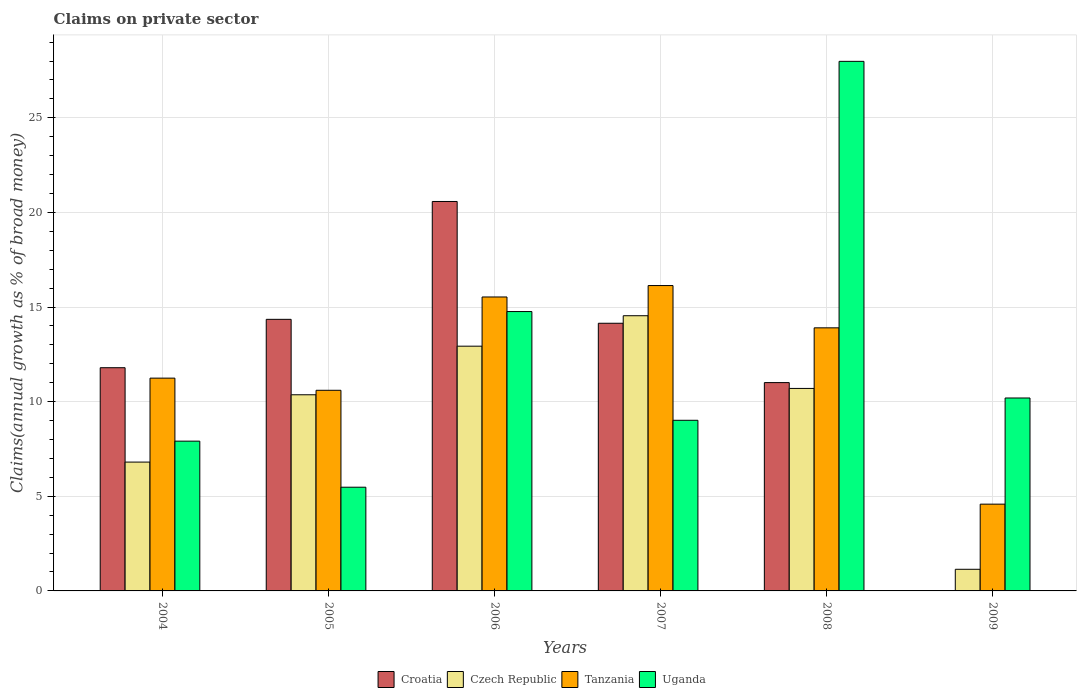How many different coloured bars are there?
Make the answer very short. 4. How many bars are there on the 1st tick from the right?
Your answer should be compact. 3. What is the percentage of broad money claimed on private sector in Czech Republic in 2007?
Provide a succinct answer. 14.54. Across all years, what is the maximum percentage of broad money claimed on private sector in Tanzania?
Offer a terse response. 16.14. In which year was the percentage of broad money claimed on private sector in Uganda maximum?
Provide a succinct answer. 2008. What is the total percentage of broad money claimed on private sector in Czech Republic in the graph?
Give a very brief answer. 56.49. What is the difference between the percentage of broad money claimed on private sector in Croatia in 2004 and that in 2006?
Provide a short and direct response. -8.78. What is the difference between the percentage of broad money claimed on private sector in Tanzania in 2005 and the percentage of broad money claimed on private sector in Croatia in 2004?
Offer a terse response. -1.19. What is the average percentage of broad money claimed on private sector in Croatia per year?
Offer a terse response. 11.98. In the year 2004, what is the difference between the percentage of broad money claimed on private sector in Tanzania and percentage of broad money claimed on private sector in Uganda?
Keep it short and to the point. 3.33. What is the ratio of the percentage of broad money claimed on private sector in Croatia in 2004 to that in 2007?
Make the answer very short. 0.83. What is the difference between the highest and the second highest percentage of broad money claimed on private sector in Croatia?
Your answer should be compact. 6.23. What is the difference between the highest and the lowest percentage of broad money claimed on private sector in Czech Republic?
Keep it short and to the point. 13.4. Is the sum of the percentage of broad money claimed on private sector in Czech Republic in 2004 and 2005 greater than the maximum percentage of broad money claimed on private sector in Croatia across all years?
Keep it short and to the point. No. Is it the case that in every year, the sum of the percentage of broad money claimed on private sector in Croatia and percentage of broad money claimed on private sector in Czech Republic is greater than the sum of percentage of broad money claimed on private sector in Uganda and percentage of broad money claimed on private sector in Tanzania?
Your response must be concise. No. How many years are there in the graph?
Provide a succinct answer. 6. Are the values on the major ticks of Y-axis written in scientific E-notation?
Offer a very short reply. No. Does the graph contain grids?
Your answer should be compact. Yes. How many legend labels are there?
Your answer should be very brief. 4. How are the legend labels stacked?
Keep it short and to the point. Horizontal. What is the title of the graph?
Give a very brief answer. Claims on private sector. Does "New Zealand" appear as one of the legend labels in the graph?
Your answer should be very brief. No. What is the label or title of the Y-axis?
Make the answer very short. Claims(annual growth as % of broad money). What is the Claims(annual growth as % of broad money) of Croatia in 2004?
Ensure brevity in your answer.  11.8. What is the Claims(annual growth as % of broad money) of Czech Republic in 2004?
Keep it short and to the point. 6.81. What is the Claims(annual growth as % of broad money) in Tanzania in 2004?
Provide a succinct answer. 11.24. What is the Claims(annual growth as % of broad money) in Uganda in 2004?
Provide a succinct answer. 7.91. What is the Claims(annual growth as % of broad money) in Croatia in 2005?
Make the answer very short. 14.35. What is the Claims(annual growth as % of broad money) in Czech Republic in 2005?
Keep it short and to the point. 10.37. What is the Claims(annual growth as % of broad money) in Tanzania in 2005?
Provide a short and direct response. 10.6. What is the Claims(annual growth as % of broad money) in Uganda in 2005?
Give a very brief answer. 5.48. What is the Claims(annual growth as % of broad money) in Croatia in 2006?
Ensure brevity in your answer.  20.58. What is the Claims(annual growth as % of broad money) in Czech Republic in 2006?
Offer a very short reply. 12.93. What is the Claims(annual growth as % of broad money) of Tanzania in 2006?
Offer a terse response. 15.53. What is the Claims(annual growth as % of broad money) in Uganda in 2006?
Make the answer very short. 14.76. What is the Claims(annual growth as % of broad money) in Croatia in 2007?
Give a very brief answer. 14.14. What is the Claims(annual growth as % of broad money) of Czech Republic in 2007?
Provide a succinct answer. 14.54. What is the Claims(annual growth as % of broad money) in Tanzania in 2007?
Give a very brief answer. 16.14. What is the Claims(annual growth as % of broad money) of Uganda in 2007?
Ensure brevity in your answer.  9.02. What is the Claims(annual growth as % of broad money) in Croatia in 2008?
Keep it short and to the point. 11.01. What is the Claims(annual growth as % of broad money) of Czech Republic in 2008?
Make the answer very short. 10.7. What is the Claims(annual growth as % of broad money) in Tanzania in 2008?
Offer a terse response. 13.9. What is the Claims(annual growth as % of broad money) in Uganda in 2008?
Provide a succinct answer. 27.98. What is the Claims(annual growth as % of broad money) of Croatia in 2009?
Your answer should be very brief. 0. What is the Claims(annual growth as % of broad money) of Czech Republic in 2009?
Make the answer very short. 1.14. What is the Claims(annual growth as % of broad money) in Tanzania in 2009?
Make the answer very short. 4.59. What is the Claims(annual growth as % of broad money) in Uganda in 2009?
Your answer should be very brief. 10.2. Across all years, what is the maximum Claims(annual growth as % of broad money) in Croatia?
Provide a short and direct response. 20.58. Across all years, what is the maximum Claims(annual growth as % of broad money) of Czech Republic?
Your answer should be very brief. 14.54. Across all years, what is the maximum Claims(annual growth as % of broad money) of Tanzania?
Give a very brief answer. 16.14. Across all years, what is the maximum Claims(annual growth as % of broad money) in Uganda?
Keep it short and to the point. 27.98. Across all years, what is the minimum Claims(annual growth as % of broad money) of Czech Republic?
Ensure brevity in your answer.  1.14. Across all years, what is the minimum Claims(annual growth as % of broad money) of Tanzania?
Offer a terse response. 4.59. Across all years, what is the minimum Claims(annual growth as % of broad money) of Uganda?
Keep it short and to the point. 5.48. What is the total Claims(annual growth as % of broad money) of Croatia in the graph?
Keep it short and to the point. 71.88. What is the total Claims(annual growth as % of broad money) in Czech Republic in the graph?
Offer a terse response. 56.49. What is the total Claims(annual growth as % of broad money) of Tanzania in the graph?
Keep it short and to the point. 72. What is the total Claims(annual growth as % of broad money) in Uganda in the graph?
Offer a terse response. 75.35. What is the difference between the Claims(annual growth as % of broad money) in Croatia in 2004 and that in 2005?
Offer a very short reply. -2.56. What is the difference between the Claims(annual growth as % of broad money) in Czech Republic in 2004 and that in 2005?
Your answer should be compact. -3.56. What is the difference between the Claims(annual growth as % of broad money) of Tanzania in 2004 and that in 2005?
Your response must be concise. 0.64. What is the difference between the Claims(annual growth as % of broad money) of Uganda in 2004 and that in 2005?
Offer a very short reply. 2.43. What is the difference between the Claims(annual growth as % of broad money) of Croatia in 2004 and that in 2006?
Your answer should be compact. -8.78. What is the difference between the Claims(annual growth as % of broad money) of Czech Republic in 2004 and that in 2006?
Your answer should be compact. -6.12. What is the difference between the Claims(annual growth as % of broad money) in Tanzania in 2004 and that in 2006?
Offer a very short reply. -4.29. What is the difference between the Claims(annual growth as % of broad money) in Uganda in 2004 and that in 2006?
Your answer should be very brief. -6.85. What is the difference between the Claims(annual growth as % of broad money) of Croatia in 2004 and that in 2007?
Your response must be concise. -2.35. What is the difference between the Claims(annual growth as % of broad money) of Czech Republic in 2004 and that in 2007?
Your answer should be very brief. -7.73. What is the difference between the Claims(annual growth as % of broad money) of Tanzania in 2004 and that in 2007?
Offer a terse response. -4.89. What is the difference between the Claims(annual growth as % of broad money) in Uganda in 2004 and that in 2007?
Ensure brevity in your answer.  -1.1. What is the difference between the Claims(annual growth as % of broad money) of Croatia in 2004 and that in 2008?
Your response must be concise. 0.79. What is the difference between the Claims(annual growth as % of broad money) of Czech Republic in 2004 and that in 2008?
Give a very brief answer. -3.89. What is the difference between the Claims(annual growth as % of broad money) in Tanzania in 2004 and that in 2008?
Provide a succinct answer. -2.66. What is the difference between the Claims(annual growth as % of broad money) of Uganda in 2004 and that in 2008?
Your answer should be very brief. -20.07. What is the difference between the Claims(annual growth as % of broad money) in Czech Republic in 2004 and that in 2009?
Give a very brief answer. 5.66. What is the difference between the Claims(annual growth as % of broad money) of Tanzania in 2004 and that in 2009?
Give a very brief answer. 6.66. What is the difference between the Claims(annual growth as % of broad money) in Uganda in 2004 and that in 2009?
Make the answer very short. -2.28. What is the difference between the Claims(annual growth as % of broad money) of Croatia in 2005 and that in 2006?
Your answer should be compact. -6.23. What is the difference between the Claims(annual growth as % of broad money) of Czech Republic in 2005 and that in 2006?
Offer a terse response. -2.57. What is the difference between the Claims(annual growth as % of broad money) of Tanzania in 2005 and that in 2006?
Provide a short and direct response. -4.93. What is the difference between the Claims(annual growth as % of broad money) in Uganda in 2005 and that in 2006?
Offer a very short reply. -9.28. What is the difference between the Claims(annual growth as % of broad money) of Croatia in 2005 and that in 2007?
Provide a short and direct response. 0.21. What is the difference between the Claims(annual growth as % of broad money) of Czech Republic in 2005 and that in 2007?
Your answer should be compact. -4.18. What is the difference between the Claims(annual growth as % of broad money) of Tanzania in 2005 and that in 2007?
Your answer should be very brief. -5.53. What is the difference between the Claims(annual growth as % of broad money) of Uganda in 2005 and that in 2007?
Make the answer very short. -3.54. What is the difference between the Claims(annual growth as % of broad money) in Croatia in 2005 and that in 2008?
Make the answer very short. 3.34. What is the difference between the Claims(annual growth as % of broad money) in Czech Republic in 2005 and that in 2008?
Give a very brief answer. -0.33. What is the difference between the Claims(annual growth as % of broad money) in Tanzania in 2005 and that in 2008?
Your answer should be compact. -3.3. What is the difference between the Claims(annual growth as % of broad money) in Uganda in 2005 and that in 2008?
Make the answer very short. -22.5. What is the difference between the Claims(annual growth as % of broad money) of Czech Republic in 2005 and that in 2009?
Your answer should be compact. 9.22. What is the difference between the Claims(annual growth as % of broad money) in Tanzania in 2005 and that in 2009?
Offer a terse response. 6.02. What is the difference between the Claims(annual growth as % of broad money) in Uganda in 2005 and that in 2009?
Provide a short and direct response. -4.71. What is the difference between the Claims(annual growth as % of broad money) of Croatia in 2006 and that in 2007?
Offer a very short reply. 6.44. What is the difference between the Claims(annual growth as % of broad money) of Czech Republic in 2006 and that in 2007?
Keep it short and to the point. -1.61. What is the difference between the Claims(annual growth as % of broad money) of Tanzania in 2006 and that in 2007?
Offer a very short reply. -0.6. What is the difference between the Claims(annual growth as % of broad money) in Uganda in 2006 and that in 2007?
Your answer should be very brief. 5.75. What is the difference between the Claims(annual growth as % of broad money) of Croatia in 2006 and that in 2008?
Offer a very short reply. 9.57. What is the difference between the Claims(annual growth as % of broad money) in Czech Republic in 2006 and that in 2008?
Offer a terse response. 2.23. What is the difference between the Claims(annual growth as % of broad money) of Tanzania in 2006 and that in 2008?
Give a very brief answer. 1.63. What is the difference between the Claims(annual growth as % of broad money) of Uganda in 2006 and that in 2008?
Ensure brevity in your answer.  -13.22. What is the difference between the Claims(annual growth as % of broad money) of Czech Republic in 2006 and that in 2009?
Provide a succinct answer. 11.79. What is the difference between the Claims(annual growth as % of broad money) in Tanzania in 2006 and that in 2009?
Give a very brief answer. 10.95. What is the difference between the Claims(annual growth as % of broad money) of Uganda in 2006 and that in 2009?
Ensure brevity in your answer.  4.57. What is the difference between the Claims(annual growth as % of broad money) in Croatia in 2007 and that in 2008?
Offer a very short reply. 3.14. What is the difference between the Claims(annual growth as % of broad money) in Czech Republic in 2007 and that in 2008?
Your answer should be very brief. 3.84. What is the difference between the Claims(annual growth as % of broad money) of Tanzania in 2007 and that in 2008?
Offer a terse response. 2.23. What is the difference between the Claims(annual growth as % of broad money) in Uganda in 2007 and that in 2008?
Your response must be concise. -18.97. What is the difference between the Claims(annual growth as % of broad money) in Czech Republic in 2007 and that in 2009?
Provide a short and direct response. 13.4. What is the difference between the Claims(annual growth as % of broad money) in Tanzania in 2007 and that in 2009?
Make the answer very short. 11.55. What is the difference between the Claims(annual growth as % of broad money) of Uganda in 2007 and that in 2009?
Make the answer very short. -1.18. What is the difference between the Claims(annual growth as % of broad money) of Czech Republic in 2008 and that in 2009?
Your answer should be compact. 9.56. What is the difference between the Claims(annual growth as % of broad money) of Tanzania in 2008 and that in 2009?
Your response must be concise. 9.32. What is the difference between the Claims(annual growth as % of broad money) of Uganda in 2008 and that in 2009?
Make the answer very short. 17.79. What is the difference between the Claims(annual growth as % of broad money) of Croatia in 2004 and the Claims(annual growth as % of broad money) of Czech Republic in 2005?
Your response must be concise. 1.43. What is the difference between the Claims(annual growth as % of broad money) of Croatia in 2004 and the Claims(annual growth as % of broad money) of Tanzania in 2005?
Keep it short and to the point. 1.19. What is the difference between the Claims(annual growth as % of broad money) of Croatia in 2004 and the Claims(annual growth as % of broad money) of Uganda in 2005?
Ensure brevity in your answer.  6.31. What is the difference between the Claims(annual growth as % of broad money) in Czech Republic in 2004 and the Claims(annual growth as % of broad money) in Tanzania in 2005?
Offer a very short reply. -3.79. What is the difference between the Claims(annual growth as % of broad money) of Czech Republic in 2004 and the Claims(annual growth as % of broad money) of Uganda in 2005?
Offer a very short reply. 1.33. What is the difference between the Claims(annual growth as % of broad money) of Tanzania in 2004 and the Claims(annual growth as % of broad money) of Uganda in 2005?
Ensure brevity in your answer.  5.76. What is the difference between the Claims(annual growth as % of broad money) in Croatia in 2004 and the Claims(annual growth as % of broad money) in Czech Republic in 2006?
Your answer should be compact. -1.14. What is the difference between the Claims(annual growth as % of broad money) of Croatia in 2004 and the Claims(annual growth as % of broad money) of Tanzania in 2006?
Your answer should be compact. -3.74. What is the difference between the Claims(annual growth as % of broad money) in Croatia in 2004 and the Claims(annual growth as % of broad money) in Uganda in 2006?
Keep it short and to the point. -2.97. What is the difference between the Claims(annual growth as % of broad money) in Czech Republic in 2004 and the Claims(annual growth as % of broad money) in Tanzania in 2006?
Offer a very short reply. -8.73. What is the difference between the Claims(annual growth as % of broad money) in Czech Republic in 2004 and the Claims(annual growth as % of broad money) in Uganda in 2006?
Offer a terse response. -7.95. What is the difference between the Claims(annual growth as % of broad money) of Tanzania in 2004 and the Claims(annual growth as % of broad money) of Uganda in 2006?
Your response must be concise. -3.52. What is the difference between the Claims(annual growth as % of broad money) of Croatia in 2004 and the Claims(annual growth as % of broad money) of Czech Republic in 2007?
Your answer should be very brief. -2.75. What is the difference between the Claims(annual growth as % of broad money) in Croatia in 2004 and the Claims(annual growth as % of broad money) in Tanzania in 2007?
Make the answer very short. -4.34. What is the difference between the Claims(annual growth as % of broad money) in Croatia in 2004 and the Claims(annual growth as % of broad money) in Uganda in 2007?
Offer a very short reply. 2.78. What is the difference between the Claims(annual growth as % of broad money) of Czech Republic in 2004 and the Claims(annual growth as % of broad money) of Tanzania in 2007?
Make the answer very short. -9.33. What is the difference between the Claims(annual growth as % of broad money) of Czech Republic in 2004 and the Claims(annual growth as % of broad money) of Uganda in 2007?
Offer a terse response. -2.21. What is the difference between the Claims(annual growth as % of broad money) of Tanzania in 2004 and the Claims(annual growth as % of broad money) of Uganda in 2007?
Make the answer very short. 2.23. What is the difference between the Claims(annual growth as % of broad money) in Croatia in 2004 and the Claims(annual growth as % of broad money) in Czech Republic in 2008?
Provide a succinct answer. 1.09. What is the difference between the Claims(annual growth as % of broad money) of Croatia in 2004 and the Claims(annual growth as % of broad money) of Tanzania in 2008?
Keep it short and to the point. -2.11. What is the difference between the Claims(annual growth as % of broad money) of Croatia in 2004 and the Claims(annual growth as % of broad money) of Uganda in 2008?
Provide a succinct answer. -16.19. What is the difference between the Claims(annual growth as % of broad money) in Czech Republic in 2004 and the Claims(annual growth as % of broad money) in Tanzania in 2008?
Offer a very short reply. -7.09. What is the difference between the Claims(annual growth as % of broad money) of Czech Republic in 2004 and the Claims(annual growth as % of broad money) of Uganda in 2008?
Provide a succinct answer. -21.18. What is the difference between the Claims(annual growth as % of broad money) in Tanzania in 2004 and the Claims(annual growth as % of broad money) in Uganda in 2008?
Make the answer very short. -16.74. What is the difference between the Claims(annual growth as % of broad money) in Croatia in 2004 and the Claims(annual growth as % of broad money) in Czech Republic in 2009?
Offer a very short reply. 10.65. What is the difference between the Claims(annual growth as % of broad money) in Croatia in 2004 and the Claims(annual growth as % of broad money) in Tanzania in 2009?
Provide a short and direct response. 7.21. What is the difference between the Claims(annual growth as % of broad money) in Croatia in 2004 and the Claims(annual growth as % of broad money) in Uganda in 2009?
Ensure brevity in your answer.  1.6. What is the difference between the Claims(annual growth as % of broad money) in Czech Republic in 2004 and the Claims(annual growth as % of broad money) in Tanzania in 2009?
Your response must be concise. 2.22. What is the difference between the Claims(annual growth as % of broad money) in Czech Republic in 2004 and the Claims(annual growth as % of broad money) in Uganda in 2009?
Provide a succinct answer. -3.39. What is the difference between the Claims(annual growth as % of broad money) in Tanzania in 2004 and the Claims(annual growth as % of broad money) in Uganda in 2009?
Your answer should be compact. 1.05. What is the difference between the Claims(annual growth as % of broad money) in Croatia in 2005 and the Claims(annual growth as % of broad money) in Czech Republic in 2006?
Make the answer very short. 1.42. What is the difference between the Claims(annual growth as % of broad money) of Croatia in 2005 and the Claims(annual growth as % of broad money) of Tanzania in 2006?
Your answer should be compact. -1.18. What is the difference between the Claims(annual growth as % of broad money) in Croatia in 2005 and the Claims(annual growth as % of broad money) in Uganda in 2006?
Provide a succinct answer. -0.41. What is the difference between the Claims(annual growth as % of broad money) in Czech Republic in 2005 and the Claims(annual growth as % of broad money) in Tanzania in 2006?
Offer a terse response. -5.17. What is the difference between the Claims(annual growth as % of broad money) in Czech Republic in 2005 and the Claims(annual growth as % of broad money) in Uganda in 2006?
Offer a very short reply. -4.4. What is the difference between the Claims(annual growth as % of broad money) of Tanzania in 2005 and the Claims(annual growth as % of broad money) of Uganda in 2006?
Offer a very short reply. -4.16. What is the difference between the Claims(annual growth as % of broad money) of Croatia in 2005 and the Claims(annual growth as % of broad money) of Czech Republic in 2007?
Give a very brief answer. -0.19. What is the difference between the Claims(annual growth as % of broad money) of Croatia in 2005 and the Claims(annual growth as % of broad money) of Tanzania in 2007?
Provide a succinct answer. -1.79. What is the difference between the Claims(annual growth as % of broad money) in Croatia in 2005 and the Claims(annual growth as % of broad money) in Uganda in 2007?
Keep it short and to the point. 5.33. What is the difference between the Claims(annual growth as % of broad money) in Czech Republic in 2005 and the Claims(annual growth as % of broad money) in Tanzania in 2007?
Your answer should be compact. -5.77. What is the difference between the Claims(annual growth as % of broad money) in Czech Republic in 2005 and the Claims(annual growth as % of broad money) in Uganda in 2007?
Your response must be concise. 1.35. What is the difference between the Claims(annual growth as % of broad money) in Tanzania in 2005 and the Claims(annual growth as % of broad money) in Uganda in 2007?
Give a very brief answer. 1.59. What is the difference between the Claims(annual growth as % of broad money) in Croatia in 2005 and the Claims(annual growth as % of broad money) in Czech Republic in 2008?
Offer a very short reply. 3.65. What is the difference between the Claims(annual growth as % of broad money) of Croatia in 2005 and the Claims(annual growth as % of broad money) of Tanzania in 2008?
Your answer should be compact. 0.45. What is the difference between the Claims(annual growth as % of broad money) in Croatia in 2005 and the Claims(annual growth as % of broad money) in Uganda in 2008?
Keep it short and to the point. -13.63. What is the difference between the Claims(annual growth as % of broad money) of Czech Republic in 2005 and the Claims(annual growth as % of broad money) of Tanzania in 2008?
Your response must be concise. -3.54. What is the difference between the Claims(annual growth as % of broad money) in Czech Republic in 2005 and the Claims(annual growth as % of broad money) in Uganda in 2008?
Provide a succinct answer. -17.62. What is the difference between the Claims(annual growth as % of broad money) of Tanzania in 2005 and the Claims(annual growth as % of broad money) of Uganda in 2008?
Your answer should be very brief. -17.38. What is the difference between the Claims(annual growth as % of broad money) in Croatia in 2005 and the Claims(annual growth as % of broad money) in Czech Republic in 2009?
Ensure brevity in your answer.  13.21. What is the difference between the Claims(annual growth as % of broad money) of Croatia in 2005 and the Claims(annual growth as % of broad money) of Tanzania in 2009?
Offer a terse response. 9.77. What is the difference between the Claims(annual growth as % of broad money) in Croatia in 2005 and the Claims(annual growth as % of broad money) in Uganda in 2009?
Offer a terse response. 4.16. What is the difference between the Claims(annual growth as % of broad money) in Czech Republic in 2005 and the Claims(annual growth as % of broad money) in Tanzania in 2009?
Ensure brevity in your answer.  5.78. What is the difference between the Claims(annual growth as % of broad money) of Czech Republic in 2005 and the Claims(annual growth as % of broad money) of Uganda in 2009?
Give a very brief answer. 0.17. What is the difference between the Claims(annual growth as % of broad money) of Tanzania in 2005 and the Claims(annual growth as % of broad money) of Uganda in 2009?
Make the answer very short. 0.41. What is the difference between the Claims(annual growth as % of broad money) in Croatia in 2006 and the Claims(annual growth as % of broad money) in Czech Republic in 2007?
Your response must be concise. 6.04. What is the difference between the Claims(annual growth as % of broad money) of Croatia in 2006 and the Claims(annual growth as % of broad money) of Tanzania in 2007?
Your response must be concise. 4.44. What is the difference between the Claims(annual growth as % of broad money) of Croatia in 2006 and the Claims(annual growth as % of broad money) of Uganda in 2007?
Offer a terse response. 11.56. What is the difference between the Claims(annual growth as % of broad money) in Czech Republic in 2006 and the Claims(annual growth as % of broad money) in Tanzania in 2007?
Provide a succinct answer. -3.2. What is the difference between the Claims(annual growth as % of broad money) of Czech Republic in 2006 and the Claims(annual growth as % of broad money) of Uganda in 2007?
Provide a short and direct response. 3.92. What is the difference between the Claims(annual growth as % of broad money) in Tanzania in 2006 and the Claims(annual growth as % of broad money) in Uganda in 2007?
Your response must be concise. 6.52. What is the difference between the Claims(annual growth as % of broad money) in Croatia in 2006 and the Claims(annual growth as % of broad money) in Czech Republic in 2008?
Offer a terse response. 9.88. What is the difference between the Claims(annual growth as % of broad money) of Croatia in 2006 and the Claims(annual growth as % of broad money) of Tanzania in 2008?
Provide a short and direct response. 6.68. What is the difference between the Claims(annual growth as % of broad money) of Croatia in 2006 and the Claims(annual growth as % of broad money) of Uganda in 2008?
Provide a succinct answer. -7.4. What is the difference between the Claims(annual growth as % of broad money) of Czech Republic in 2006 and the Claims(annual growth as % of broad money) of Tanzania in 2008?
Provide a short and direct response. -0.97. What is the difference between the Claims(annual growth as % of broad money) in Czech Republic in 2006 and the Claims(annual growth as % of broad money) in Uganda in 2008?
Give a very brief answer. -15.05. What is the difference between the Claims(annual growth as % of broad money) in Tanzania in 2006 and the Claims(annual growth as % of broad money) in Uganda in 2008?
Make the answer very short. -12.45. What is the difference between the Claims(annual growth as % of broad money) of Croatia in 2006 and the Claims(annual growth as % of broad money) of Czech Republic in 2009?
Your answer should be very brief. 19.44. What is the difference between the Claims(annual growth as % of broad money) of Croatia in 2006 and the Claims(annual growth as % of broad money) of Tanzania in 2009?
Provide a succinct answer. 15.99. What is the difference between the Claims(annual growth as % of broad money) of Croatia in 2006 and the Claims(annual growth as % of broad money) of Uganda in 2009?
Your answer should be very brief. 10.38. What is the difference between the Claims(annual growth as % of broad money) of Czech Republic in 2006 and the Claims(annual growth as % of broad money) of Tanzania in 2009?
Provide a succinct answer. 8.35. What is the difference between the Claims(annual growth as % of broad money) of Czech Republic in 2006 and the Claims(annual growth as % of broad money) of Uganda in 2009?
Provide a succinct answer. 2.74. What is the difference between the Claims(annual growth as % of broad money) in Tanzania in 2006 and the Claims(annual growth as % of broad money) in Uganda in 2009?
Offer a very short reply. 5.34. What is the difference between the Claims(annual growth as % of broad money) in Croatia in 2007 and the Claims(annual growth as % of broad money) in Czech Republic in 2008?
Give a very brief answer. 3.44. What is the difference between the Claims(annual growth as % of broad money) in Croatia in 2007 and the Claims(annual growth as % of broad money) in Tanzania in 2008?
Give a very brief answer. 0.24. What is the difference between the Claims(annual growth as % of broad money) in Croatia in 2007 and the Claims(annual growth as % of broad money) in Uganda in 2008?
Provide a short and direct response. -13.84. What is the difference between the Claims(annual growth as % of broad money) of Czech Republic in 2007 and the Claims(annual growth as % of broad money) of Tanzania in 2008?
Offer a very short reply. 0.64. What is the difference between the Claims(annual growth as % of broad money) of Czech Republic in 2007 and the Claims(annual growth as % of broad money) of Uganda in 2008?
Offer a very short reply. -13.44. What is the difference between the Claims(annual growth as % of broad money) in Tanzania in 2007 and the Claims(annual growth as % of broad money) in Uganda in 2008?
Your answer should be compact. -11.85. What is the difference between the Claims(annual growth as % of broad money) of Croatia in 2007 and the Claims(annual growth as % of broad money) of Czech Republic in 2009?
Your answer should be compact. 13. What is the difference between the Claims(annual growth as % of broad money) in Croatia in 2007 and the Claims(annual growth as % of broad money) in Tanzania in 2009?
Your answer should be very brief. 9.56. What is the difference between the Claims(annual growth as % of broad money) of Croatia in 2007 and the Claims(annual growth as % of broad money) of Uganda in 2009?
Your answer should be very brief. 3.95. What is the difference between the Claims(annual growth as % of broad money) of Czech Republic in 2007 and the Claims(annual growth as % of broad money) of Tanzania in 2009?
Provide a short and direct response. 9.96. What is the difference between the Claims(annual growth as % of broad money) in Czech Republic in 2007 and the Claims(annual growth as % of broad money) in Uganda in 2009?
Give a very brief answer. 4.35. What is the difference between the Claims(annual growth as % of broad money) of Tanzania in 2007 and the Claims(annual growth as % of broad money) of Uganda in 2009?
Offer a terse response. 5.94. What is the difference between the Claims(annual growth as % of broad money) of Croatia in 2008 and the Claims(annual growth as % of broad money) of Czech Republic in 2009?
Provide a short and direct response. 9.87. What is the difference between the Claims(annual growth as % of broad money) in Croatia in 2008 and the Claims(annual growth as % of broad money) in Tanzania in 2009?
Your answer should be very brief. 6.42. What is the difference between the Claims(annual growth as % of broad money) in Croatia in 2008 and the Claims(annual growth as % of broad money) in Uganda in 2009?
Ensure brevity in your answer.  0.81. What is the difference between the Claims(annual growth as % of broad money) of Czech Republic in 2008 and the Claims(annual growth as % of broad money) of Tanzania in 2009?
Give a very brief answer. 6.11. What is the difference between the Claims(annual growth as % of broad money) of Czech Republic in 2008 and the Claims(annual growth as % of broad money) of Uganda in 2009?
Keep it short and to the point. 0.5. What is the difference between the Claims(annual growth as % of broad money) of Tanzania in 2008 and the Claims(annual growth as % of broad money) of Uganda in 2009?
Make the answer very short. 3.71. What is the average Claims(annual growth as % of broad money) of Croatia per year?
Keep it short and to the point. 11.98. What is the average Claims(annual growth as % of broad money) of Czech Republic per year?
Give a very brief answer. 9.42. What is the average Claims(annual growth as % of broad money) of Tanzania per year?
Ensure brevity in your answer.  12. What is the average Claims(annual growth as % of broad money) in Uganda per year?
Provide a short and direct response. 12.56. In the year 2004, what is the difference between the Claims(annual growth as % of broad money) of Croatia and Claims(annual growth as % of broad money) of Czech Republic?
Offer a very short reply. 4.99. In the year 2004, what is the difference between the Claims(annual growth as % of broad money) in Croatia and Claims(annual growth as % of broad money) in Tanzania?
Ensure brevity in your answer.  0.55. In the year 2004, what is the difference between the Claims(annual growth as % of broad money) of Croatia and Claims(annual growth as % of broad money) of Uganda?
Keep it short and to the point. 3.88. In the year 2004, what is the difference between the Claims(annual growth as % of broad money) in Czech Republic and Claims(annual growth as % of broad money) in Tanzania?
Give a very brief answer. -4.44. In the year 2004, what is the difference between the Claims(annual growth as % of broad money) of Czech Republic and Claims(annual growth as % of broad money) of Uganda?
Your answer should be very brief. -1.11. In the year 2004, what is the difference between the Claims(annual growth as % of broad money) of Tanzania and Claims(annual growth as % of broad money) of Uganda?
Your answer should be very brief. 3.33. In the year 2005, what is the difference between the Claims(annual growth as % of broad money) of Croatia and Claims(annual growth as % of broad money) of Czech Republic?
Offer a terse response. 3.99. In the year 2005, what is the difference between the Claims(annual growth as % of broad money) in Croatia and Claims(annual growth as % of broad money) in Tanzania?
Offer a terse response. 3.75. In the year 2005, what is the difference between the Claims(annual growth as % of broad money) in Croatia and Claims(annual growth as % of broad money) in Uganda?
Give a very brief answer. 8.87. In the year 2005, what is the difference between the Claims(annual growth as % of broad money) in Czech Republic and Claims(annual growth as % of broad money) in Tanzania?
Provide a succinct answer. -0.24. In the year 2005, what is the difference between the Claims(annual growth as % of broad money) of Czech Republic and Claims(annual growth as % of broad money) of Uganda?
Ensure brevity in your answer.  4.88. In the year 2005, what is the difference between the Claims(annual growth as % of broad money) of Tanzania and Claims(annual growth as % of broad money) of Uganda?
Your answer should be very brief. 5.12. In the year 2006, what is the difference between the Claims(annual growth as % of broad money) of Croatia and Claims(annual growth as % of broad money) of Czech Republic?
Your answer should be compact. 7.65. In the year 2006, what is the difference between the Claims(annual growth as % of broad money) of Croatia and Claims(annual growth as % of broad money) of Tanzania?
Provide a short and direct response. 5.05. In the year 2006, what is the difference between the Claims(annual growth as % of broad money) in Croatia and Claims(annual growth as % of broad money) in Uganda?
Provide a succinct answer. 5.82. In the year 2006, what is the difference between the Claims(annual growth as % of broad money) of Czech Republic and Claims(annual growth as % of broad money) of Tanzania?
Make the answer very short. -2.6. In the year 2006, what is the difference between the Claims(annual growth as % of broad money) in Czech Republic and Claims(annual growth as % of broad money) in Uganda?
Provide a succinct answer. -1.83. In the year 2006, what is the difference between the Claims(annual growth as % of broad money) in Tanzania and Claims(annual growth as % of broad money) in Uganda?
Offer a very short reply. 0.77. In the year 2007, what is the difference between the Claims(annual growth as % of broad money) of Croatia and Claims(annual growth as % of broad money) of Czech Republic?
Your answer should be very brief. -0.4. In the year 2007, what is the difference between the Claims(annual growth as % of broad money) in Croatia and Claims(annual growth as % of broad money) in Tanzania?
Your response must be concise. -1.99. In the year 2007, what is the difference between the Claims(annual growth as % of broad money) in Croatia and Claims(annual growth as % of broad money) in Uganda?
Make the answer very short. 5.13. In the year 2007, what is the difference between the Claims(annual growth as % of broad money) in Czech Republic and Claims(annual growth as % of broad money) in Tanzania?
Your answer should be very brief. -1.59. In the year 2007, what is the difference between the Claims(annual growth as % of broad money) in Czech Republic and Claims(annual growth as % of broad money) in Uganda?
Keep it short and to the point. 5.53. In the year 2007, what is the difference between the Claims(annual growth as % of broad money) in Tanzania and Claims(annual growth as % of broad money) in Uganda?
Provide a short and direct response. 7.12. In the year 2008, what is the difference between the Claims(annual growth as % of broad money) in Croatia and Claims(annual growth as % of broad money) in Czech Republic?
Offer a very short reply. 0.31. In the year 2008, what is the difference between the Claims(annual growth as % of broad money) of Croatia and Claims(annual growth as % of broad money) of Tanzania?
Provide a short and direct response. -2.89. In the year 2008, what is the difference between the Claims(annual growth as % of broad money) in Croatia and Claims(annual growth as % of broad money) in Uganda?
Your answer should be very brief. -16.98. In the year 2008, what is the difference between the Claims(annual growth as % of broad money) of Czech Republic and Claims(annual growth as % of broad money) of Tanzania?
Keep it short and to the point. -3.2. In the year 2008, what is the difference between the Claims(annual growth as % of broad money) of Czech Republic and Claims(annual growth as % of broad money) of Uganda?
Ensure brevity in your answer.  -17.28. In the year 2008, what is the difference between the Claims(annual growth as % of broad money) of Tanzania and Claims(annual growth as % of broad money) of Uganda?
Offer a terse response. -14.08. In the year 2009, what is the difference between the Claims(annual growth as % of broad money) of Czech Republic and Claims(annual growth as % of broad money) of Tanzania?
Keep it short and to the point. -3.44. In the year 2009, what is the difference between the Claims(annual growth as % of broad money) of Czech Republic and Claims(annual growth as % of broad money) of Uganda?
Your answer should be compact. -9.05. In the year 2009, what is the difference between the Claims(annual growth as % of broad money) in Tanzania and Claims(annual growth as % of broad money) in Uganda?
Give a very brief answer. -5.61. What is the ratio of the Claims(annual growth as % of broad money) in Croatia in 2004 to that in 2005?
Offer a very short reply. 0.82. What is the ratio of the Claims(annual growth as % of broad money) of Czech Republic in 2004 to that in 2005?
Give a very brief answer. 0.66. What is the ratio of the Claims(annual growth as % of broad money) of Tanzania in 2004 to that in 2005?
Give a very brief answer. 1.06. What is the ratio of the Claims(annual growth as % of broad money) of Uganda in 2004 to that in 2005?
Offer a terse response. 1.44. What is the ratio of the Claims(annual growth as % of broad money) in Croatia in 2004 to that in 2006?
Keep it short and to the point. 0.57. What is the ratio of the Claims(annual growth as % of broad money) in Czech Republic in 2004 to that in 2006?
Offer a terse response. 0.53. What is the ratio of the Claims(annual growth as % of broad money) in Tanzania in 2004 to that in 2006?
Offer a very short reply. 0.72. What is the ratio of the Claims(annual growth as % of broad money) in Uganda in 2004 to that in 2006?
Offer a very short reply. 0.54. What is the ratio of the Claims(annual growth as % of broad money) of Croatia in 2004 to that in 2007?
Ensure brevity in your answer.  0.83. What is the ratio of the Claims(annual growth as % of broad money) in Czech Republic in 2004 to that in 2007?
Make the answer very short. 0.47. What is the ratio of the Claims(annual growth as % of broad money) of Tanzania in 2004 to that in 2007?
Make the answer very short. 0.7. What is the ratio of the Claims(annual growth as % of broad money) in Uganda in 2004 to that in 2007?
Offer a very short reply. 0.88. What is the ratio of the Claims(annual growth as % of broad money) in Croatia in 2004 to that in 2008?
Provide a succinct answer. 1.07. What is the ratio of the Claims(annual growth as % of broad money) of Czech Republic in 2004 to that in 2008?
Provide a succinct answer. 0.64. What is the ratio of the Claims(annual growth as % of broad money) in Tanzania in 2004 to that in 2008?
Offer a terse response. 0.81. What is the ratio of the Claims(annual growth as % of broad money) of Uganda in 2004 to that in 2008?
Ensure brevity in your answer.  0.28. What is the ratio of the Claims(annual growth as % of broad money) in Czech Republic in 2004 to that in 2009?
Make the answer very short. 5.96. What is the ratio of the Claims(annual growth as % of broad money) in Tanzania in 2004 to that in 2009?
Ensure brevity in your answer.  2.45. What is the ratio of the Claims(annual growth as % of broad money) of Uganda in 2004 to that in 2009?
Your answer should be very brief. 0.78. What is the ratio of the Claims(annual growth as % of broad money) in Croatia in 2005 to that in 2006?
Provide a succinct answer. 0.7. What is the ratio of the Claims(annual growth as % of broad money) in Czech Republic in 2005 to that in 2006?
Make the answer very short. 0.8. What is the ratio of the Claims(annual growth as % of broad money) in Tanzania in 2005 to that in 2006?
Offer a terse response. 0.68. What is the ratio of the Claims(annual growth as % of broad money) in Uganda in 2005 to that in 2006?
Make the answer very short. 0.37. What is the ratio of the Claims(annual growth as % of broad money) in Croatia in 2005 to that in 2007?
Offer a very short reply. 1.01. What is the ratio of the Claims(annual growth as % of broad money) of Czech Republic in 2005 to that in 2007?
Offer a terse response. 0.71. What is the ratio of the Claims(annual growth as % of broad money) of Tanzania in 2005 to that in 2007?
Give a very brief answer. 0.66. What is the ratio of the Claims(annual growth as % of broad money) in Uganda in 2005 to that in 2007?
Your answer should be very brief. 0.61. What is the ratio of the Claims(annual growth as % of broad money) in Croatia in 2005 to that in 2008?
Give a very brief answer. 1.3. What is the ratio of the Claims(annual growth as % of broad money) of Czech Republic in 2005 to that in 2008?
Make the answer very short. 0.97. What is the ratio of the Claims(annual growth as % of broad money) of Tanzania in 2005 to that in 2008?
Offer a terse response. 0.76. What is the ratio of the Claims(annual growth as % of broad money) in Uganda in 2005 to that in 2008?
Your answer should be very brief. 0.2. What is the ratio of the Claims(annual growth as % of broad money) in Czech Republic in 2005 to that in 2009?
Provide a short and direct response. 9.07. What is the ratio of the Claims(annual growth as % of broad money) in Tanzania in 2005 to that in 2009?
Keep it short and to the point. 2.31. What is the ratio of the Claims(annual growth as % of broad money) in Uganda in 2005 to that in 2009?
Make the answer very short. 0.54. What is the ratio of the Claims(annual growth as % of broad money) of Croatia in 2006 to that in 2007?
Your answer should be very brief. 1.46. What is the ratio of the Claims(annual growth as % of broad money) in Czech Republic in 2006 to that in 2007?
Give a very brief answer. 0.89. What is the ratio of the Claims(annual growth as % of broad money) of Tanzania in 2006 to that in 2007?
Ensure brevity in your answer.  0.96. What is the ratio of the Claims(annual growth as % of broad money) of Uganda in 2006 to that in 2007?
Your answer should be compact. 1.64. What is the ratio of the Claims(annual growth as % of broad money) of Croatia in 2006 to that in 2008?
Provide a succinct answer. 1.87. What is the ratio of the Claims(annual growth as % of broad money) in Czech Republic in 2006 to that in 2008?
Offer a terse response. 1.21. What is the ratio of the Claims(annual growth as % of broad money) of Tanzania in 2006 to that in 2008?
Provide a short and direct response. 1.12. What is the ratio of the Claims(annual growth as % of broad money) in Uganda in 2006 to that in 2008?
Keep it short and to the point. 0.53. What is the ratio of the Claims(annual growth as % of broad money) in Czech Republic in 2006 to that in 2009?
Offer a terse response. 11.31. What is the ratio of the Claims(annual growth as % of broad money) of Tanzania in 2006 to that in 2009?
Give a very brief answer. 3.39. What is the ratio of the Claims(annual growth as % of broad money) in Uganda in 2006 to that in 2009?
Offer a very short reply. 1.45. What is the ratio of the Claims(annual growth as % of broad money) in Croatia in 2007 to that in 2008?
Your response must be concise. 1.28. What is the ratio of the Claims(annual growth as % of broad money) in Czech Republic in 2007 to that in 2008?
Make the answer very short. 1.36. What is the ratio of the Claims(annual growth as % of broad money) in Tanzania in 2007 to that in 2008?
Your answer should be compact. 1.16. What is the ratio of the Claims(annual growth as % of broad money) of Uganda in 2007 to that in 2008?
Offer a terse response. 0.32. What is the ratio of the Claims(annual growth as % of broad money) in Czech Republic in 2007 to that in 2009?
Your answer should be very brief. 12.72. What is the ratio of the Claims(annual growth as % of broad money) in Tanzania in 2007 to that in 2009?
Provide a short and direct response. 3.52. What is the ratio of the Claims(annual growth as % of broad money) in Uganda in 2007 to that in 2009?
Your answer should be compact. 0.88. What is the ratio of the Claims(annual growth as % of broad money) of Czech Republic in 2008 to that in 2009?
Provide a succinct answer. 9.36. What is the ratio of the Claims(annual growth as % of broad money) in Tanzania in 2008 to that in 2009?
Offer a very short reply. 3.03. What is the ratio of the Claims(annual growth as % of broad money) of Uganda in 2008 to that in 2009?
Offer a terse response. 2.74. What is the difference between the highest and the second highest Claims(annual growth as % of broad money) of Croatia?
Ensure brevity in your answer.  6.23. What is the difference between the highest and the second highest Claims(annual growth as % of broad money) of Czech Republic?
Make the answer very short. 1.61. What is the difference between the highest and the second highest Claims(annual growth as % of broad money) of Tanzania?
Offer a very short reply. 0.6. What is the difference between the highest and the second highest Claims(annual growth as % of broad money) in Uganda?
Your answer should be very brief. 13.22. What is the difference between the highest and the lowest Claims(annual growth as % of broad money) in Croatia?
Your answer should be compact. 20.58. What is the difference between the highest and the lowest Claims(annual growth as % of broad money) of Czech Republic?
Give a very brief answer. 13.4. What is the difference between the highest and the lowest Claims(annual growth as % of broad money) of Tanzania?
Keep it short and to the point. 11.55. What is the difference between the highest and the lowest Claims(annual growth as % of broad money) in Uganda?
Keep it short and to the point. 22.5. 